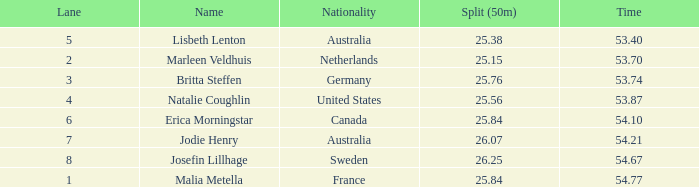In lanes above 8, what is the combined total of 50m splits for josefin lillhage? None. 